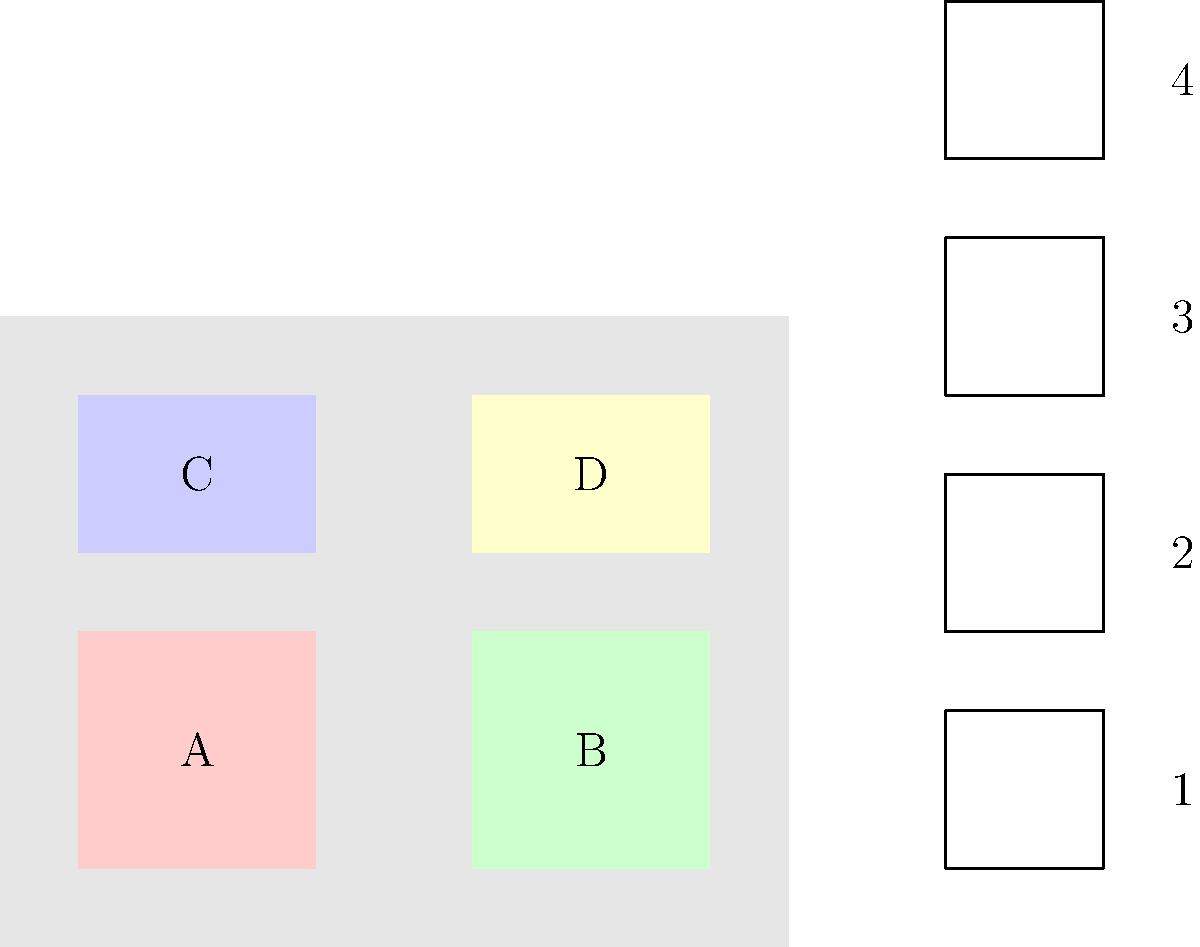Match the traditional Hungarian costumes (1-4) to their corresponding regions (A-D) on the map of Hungary. To match the traditional Hungarian costumes to their corresponding regions, we need to consider the characteristics of each costume and the cultural heritage of each region:

1. Region A (Northwest): This region, known as Transdanubia, is associated with costume 2. The costume features embroidered vests and full skirts, typical of the Transdanubian style.

2. Region B (Northeast): This area, including the Great Plains, is linked to costume 1. The costume shows the characteristic wide, loose-fitting garments and elaborate embroidery of the Hungarian Plains.

3. Region C (Southwest): This region, including parts of Southern Transdanubia, corresponds to costume 4. The costume displays the colorful embroidery and layered skirts typical of this area.

4. Region D (Southeast): This region, encompassing parts of the Southern Great Plains, matches with costume 3. The costume exhibits the ornate headwear and richly decorated outfits characteristic of this area.

By analyzing the distinctive features of each costume and understanding the cultural traditions of different Hungarian regions, we can accurately match the costumes to their corresponding areas on the map.
Answer: A-2, B-1, C-4, D-3 